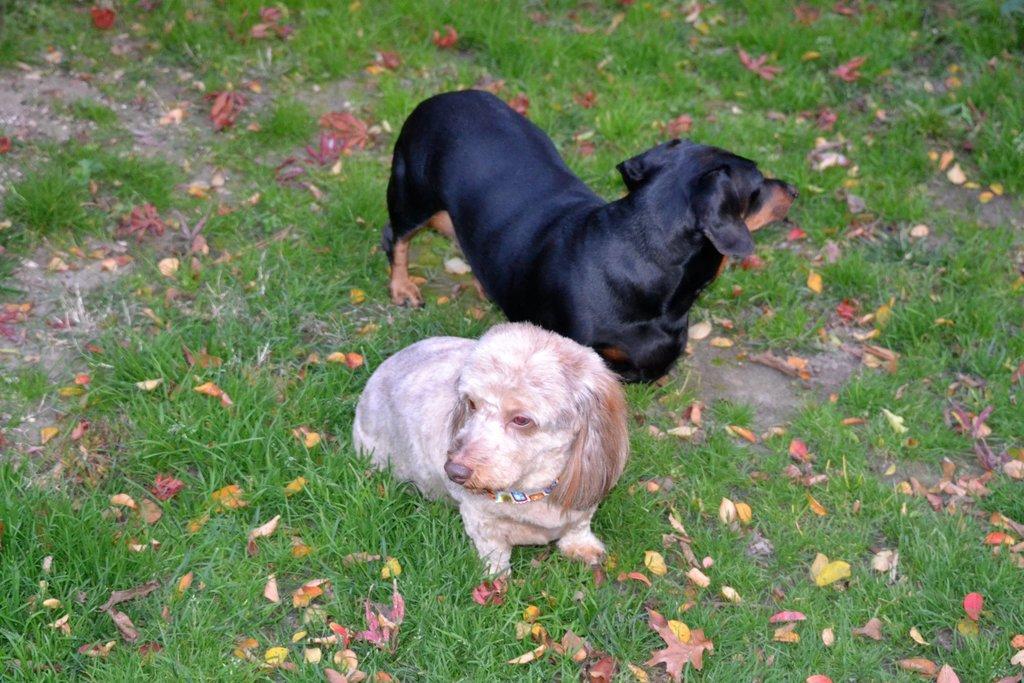Describe this image in one or two sentences. In this image I can see two dogs in brown, white and black color. I can see few dry leaves and the green grass on the ground. 